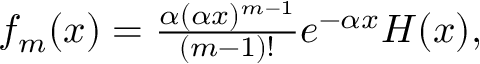Convert formula to latex. <formula><loc_0><loc_0><loc_500><loc_500>\begin{array} { r } { f _ { m } ( x ) = \frac { \alpha ( \alpha x ) ^ { m - 1 } } { ( m - 1 ) ! } e ^ { - \alpha x } H ( x ) , } \end{array}</formula> 